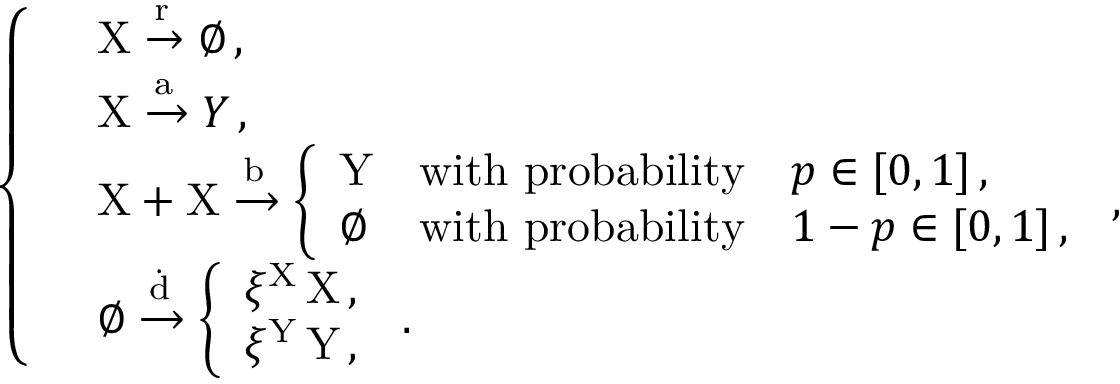Convert formula to latex. <formula><loc_0><loc_0><loc_500><loc_500>\left \{ \begin{array} { l l } & { X \xrightarrow { r } \emptyset \, , } \\ & { X \xrightarrow { a } Y \, , } \\ & { X + X \xrightarrow { b } \left \{ \begin{array} { l l } { Y } & { w i t h p r o b a b i l i t y \quad p \in [ 0 , 1 ] \, , } \\ { \emptyset } & { w i t h p r o b a b i l i t y \quad 1 - p \in [ 0 , 1 ] \, , } \end{array} \, , } \\ & { \emptyset \xrightarrow { \dot { d } } \left \{ \begin{array} { l l } { \xi ^ { X } \, X \, , } \\ { \xi ^ { Y } \, Y \, , } \end{array} \, . } \end{array}</formula> 